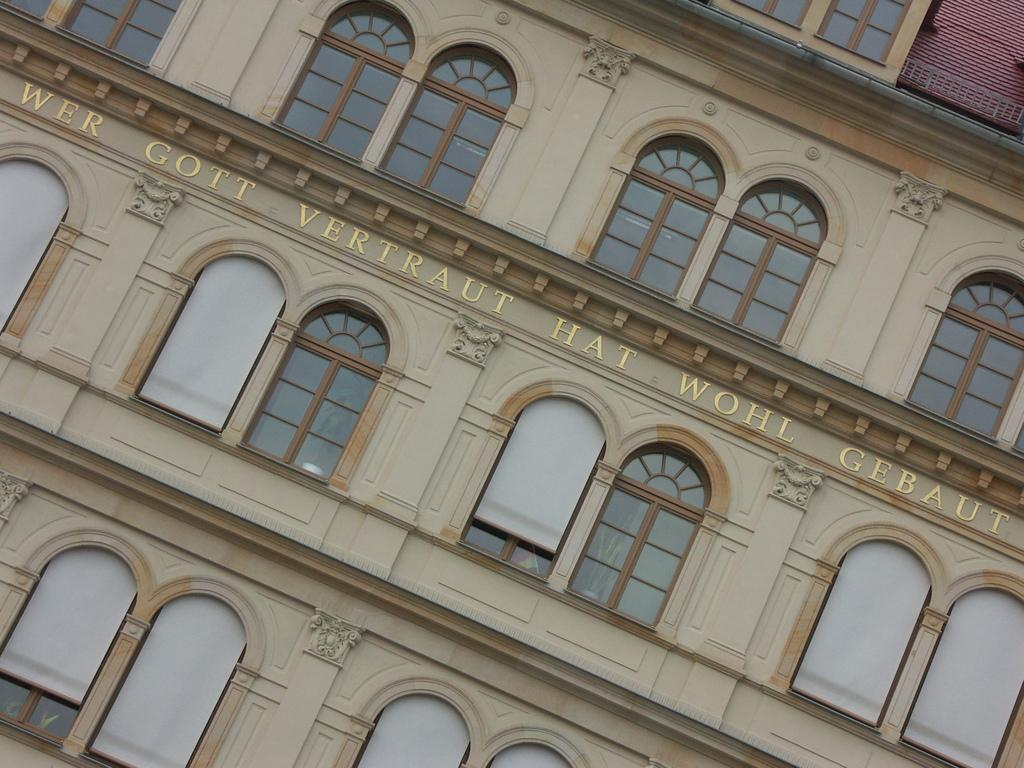What type of structure is visible in the image? There is a building in the image. What feature can be observed on the building? The building has glass windows. What colors are used for the building? The building is in cream and brown color. Is there any text or symbols on the building? Yes, there is writing on the building. Can you tell me how many bees are flying around the building in the image? There are no bees visible in the image. Is there a bike parked in front of the building in the image? There is no bike present in the image. 